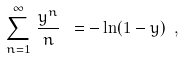Convert formula to latex. <formula><loc_0><loc_0><loc_500><loc_500>\sum ^ { \infty } _ { n = 1 } \, \frac { y ^ { n } } { n } \ = - \ln ( 1 - y ) \ ,</formula> 